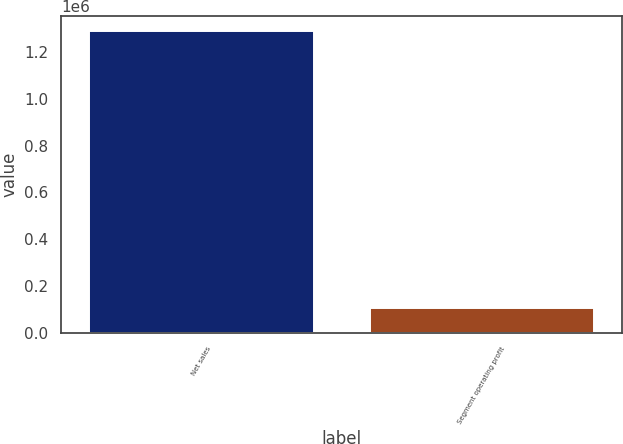<chart> <loc_0><loc_0><loc_500><loc_500><bar_chart><fcel>Net sales<fcel>Segment operating profit<nl><fcel>1.28931e+06<fcel>105057<nl></chart> 